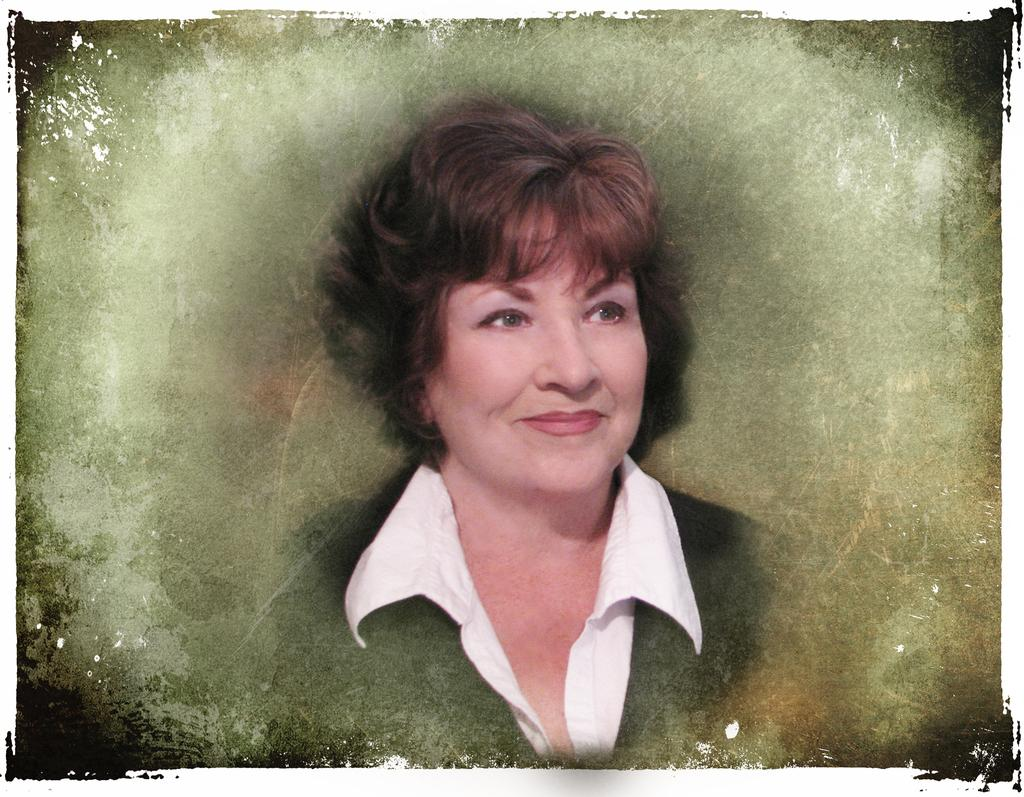What is the main subject of the image? The main subject of the image is a woman. What is the woman wearing on her upper body? The woman is wearing a white shirt and a black coat. What year is depicted in the image? The provided facts do not mention any specific year, and there is no indication of a year in the image. 